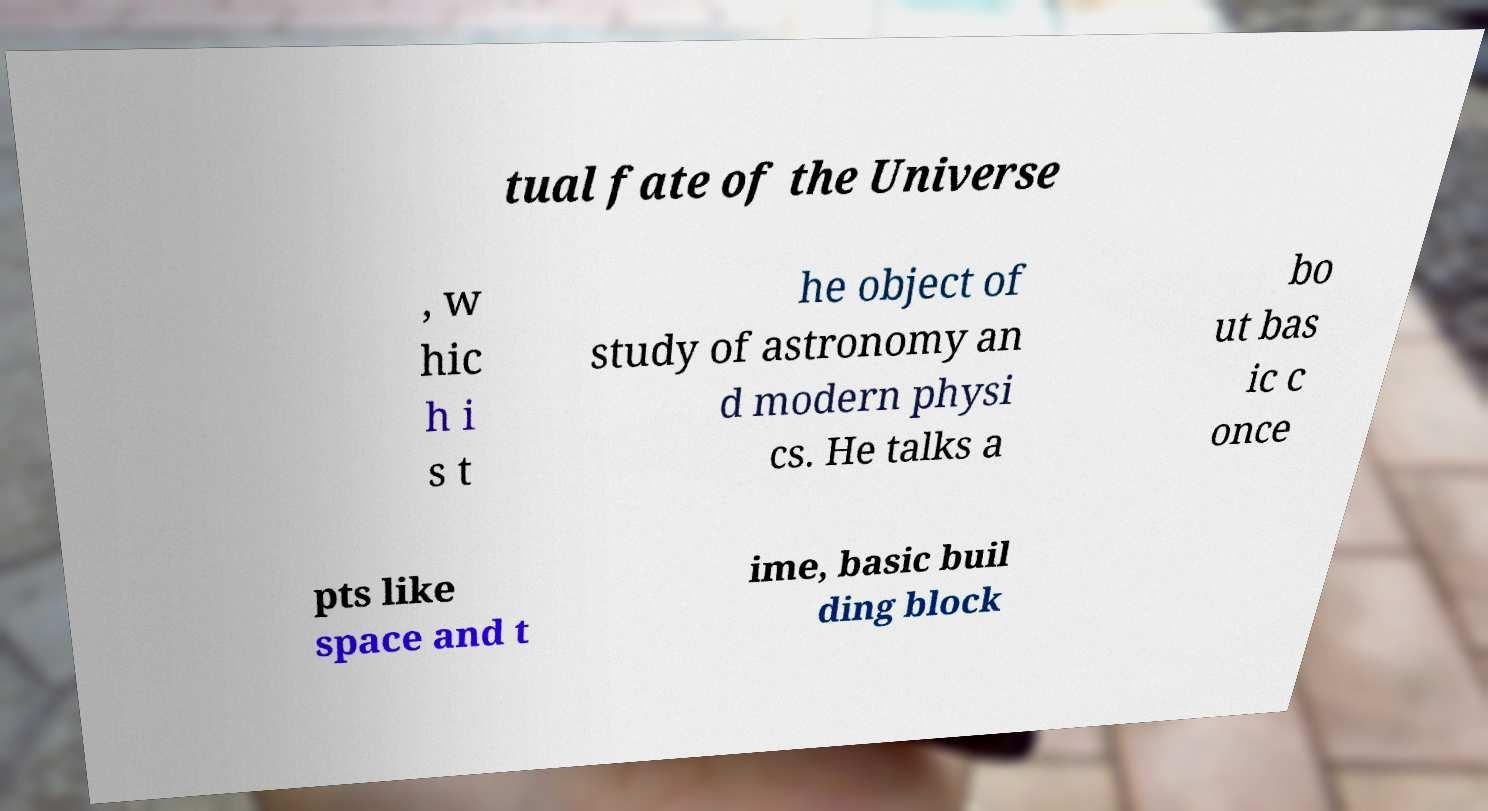Can you read and provide the text displayed in the image?This photo seems to have some interesting text. Can you extract and type it out for me? tual fate of the Universe , w hic h i s t he object of study of astronomy an d modern physi cs. He talks a bo ut bas ic c once pts like space and t ime, basic buil ding block 